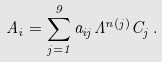Convert formula to latex. <formula><loc_0><loc_0><loc_500><loc_500>A _ { i } = \sum _ { j = 1 } ^ { 9 } a _ { i j } \Lambda ^ { n ( j ) } C _ { j } \, .</formula> 